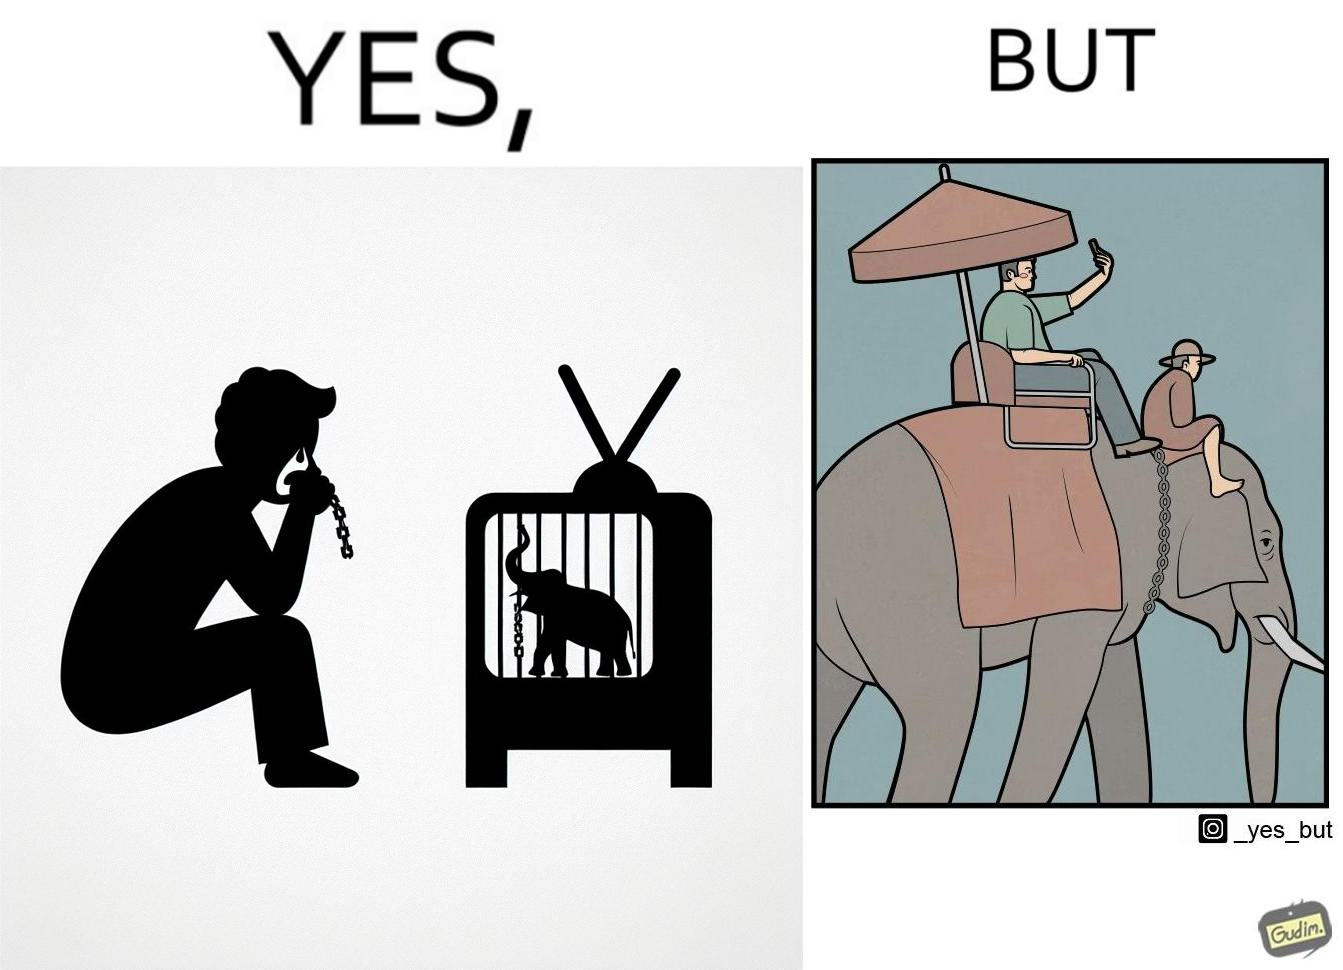Describe the contrast between the left and right parts of this image. In the left part of the image: a man crying on seeing an elephant being chained in a cage in a TV program In the right part of the image: a person riding an elephant while taking selfies 